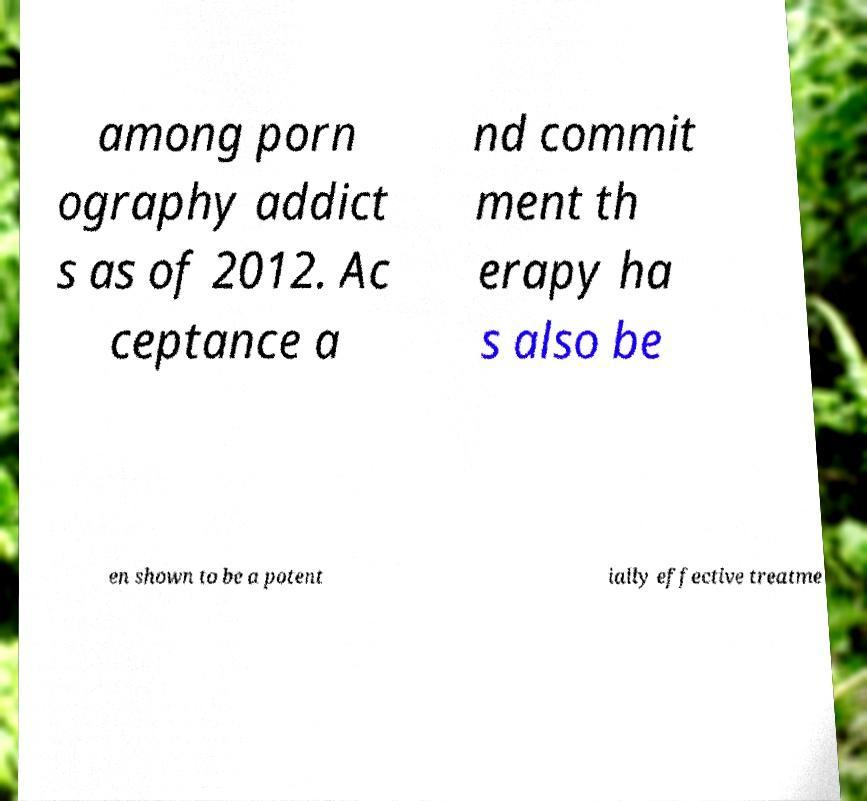For documentation purposes, I need the text within this image transcribed. Could you provide that? among porn ography addict s as of 2012. Ac ceptance a nd commit ment th erapy ha s also be en shown to be a potent ially effective treatme 